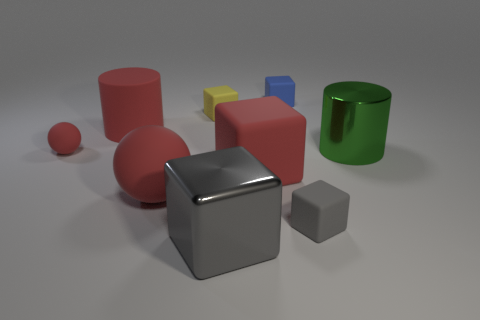Subtract 2 blocks. How many blocks are left? 3 Subtract all red cubes. How many cubes are left? 4 Subtract all blue rubber cubes. How many cubes are left? 4 Subtract all green spheres. Subtract all gray cylinders. How many spheres are left? 2 Add 1 green shiny cylinders. How many objects exist? 10 Subtract all cylinders. How many objects are left? 7 Subtract all red blocks. Subtract all large metal cylinders. How many objects are left? 7 Add 3 gray shiny objects. How many gray shiny objects are left? 4 Add 8 red cylinders. How many red cylinders exist? 9 Subtract 0 gray cylinders. How many objects are left? 9 